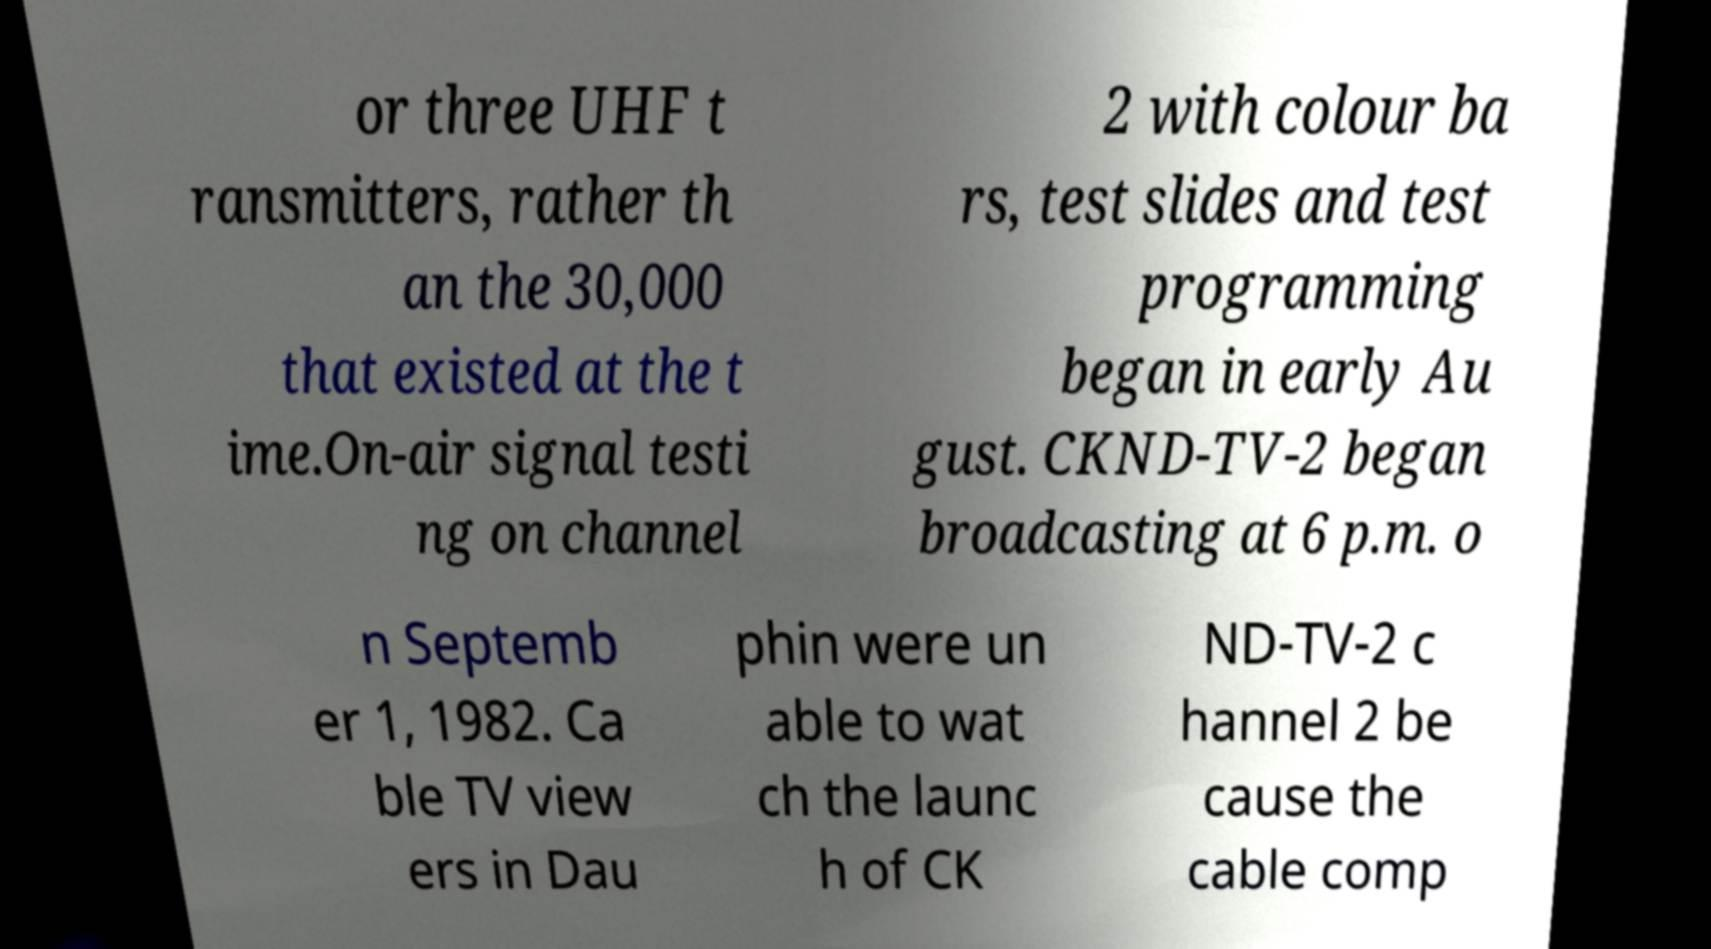Can you accurately transcribe the text from the provided image for me? or three UHF t ransmitters, rather th an the 30,000 that existed at the t ime.On-air signal testi ng on channel 2 with colour ba rs, test slides and test programming began in early Au gust. CKND-TV-2 began broadcasting at 6 p.m. o n Septemb er 1, 1982. Ca ble TV view ers in Dau phin were un able to wat ch the launc h of CK ND-TV-2 c hannel 2 be cause the cable comp 